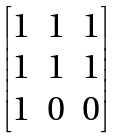Convert formula to latex. <formula><loc_0><loc_0><loc_500><loc_500>\begin{bmatrix} 1 & 1 & 1 \\ 1 & 1 & 1 \\ 1 & 0 & 0 \\ \end{bmatrix}</formula> 